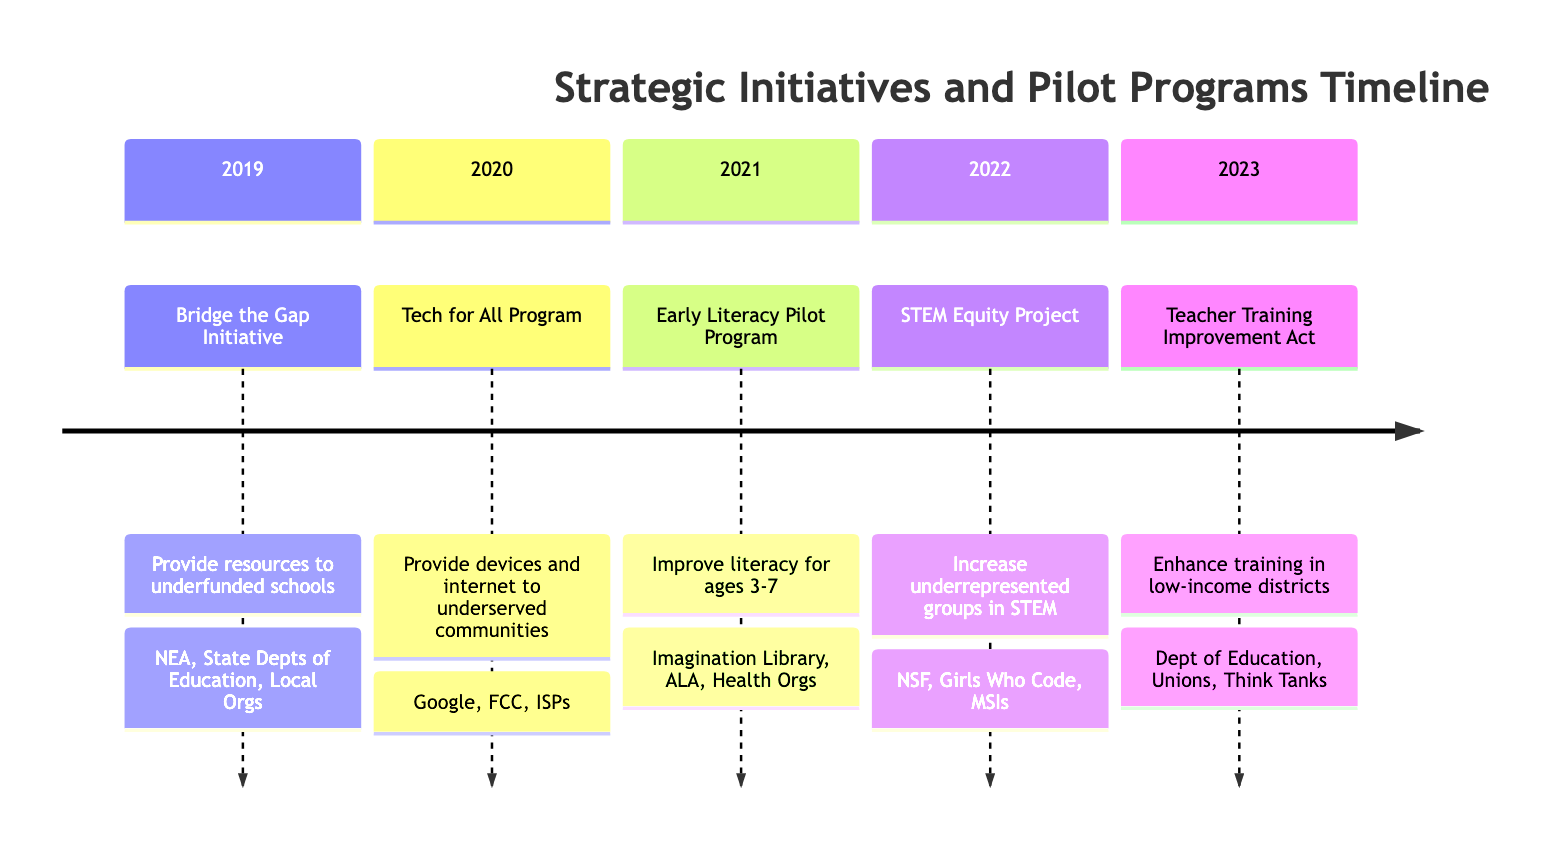What initiative was launched in 2019? The diagram shows that the initiative launched in 2019 is the "Bridge the Gap Initiative." This can be directly identified from the associated year section of the timeline.
Answer: Bridge the Gap Initiative How many initiatives were launched by 2021? By counting the number of initiatives listed from 2019 to 2021 in the timeline, I see there are three: the Bridge the Gap Initiative, the Tech for All Program, and the Early Literacy Pilot Program.
Answer: 3 Which initiative aimed to improve early literacy skills? Referring to the entry for the year 2021, the initiative focused on improving early literacy skills among children aged 3-7 is identified as the "Early Literacy Pilot Program."
Answer: Early Literacy Pilot Program In which year was the STEM Equity Project launched? The timeline lists the STEM Equity Project under the year 2022, making it clear when this initiative was launched.
Answer: 2022 What is the main goal of the Teacher Training Improvement Act? According to the description for the year 2023, the main goal of the Teacher Training Improvement Act is to provide comprehensive training programs for teachers in low-income districts.
Answer: Enhance training in low-income districts Which organizations collaborated on the Tech for All Program? The diagram specifies that the collaborators for the Tech for All Program are Google for Education, the Federal Communication Commission, and local Internet Service Providers. By grouping this information, I can identify the collaborators.
Answer: Google for Education, Federal Communication Commission, Local Internet Service Providers What was the focus of the STEM Equity Project? The focus of the STEM Equity Project, as noted in the diagram under 2022, was to increase participation of underrepresented groups in STEM education through mentorship and after-school programs.
Answer: Increase participation of underrepresented groups in STEM How many collaborators supported the Early Literacy Pilot Program? From the 2021 section of the timeline, the Early Literacy Pilot Program had three collaborators: Dolly Parton's Imagination Library, the American Library Association, and Pediatric Health Organizations.
Answer: 3 Which initiative was focused on technology access? The initiative focused on technology access is the "Tech for All Program," as stated in the 2020 section of the timeline.
Answer: Tech for All Program 